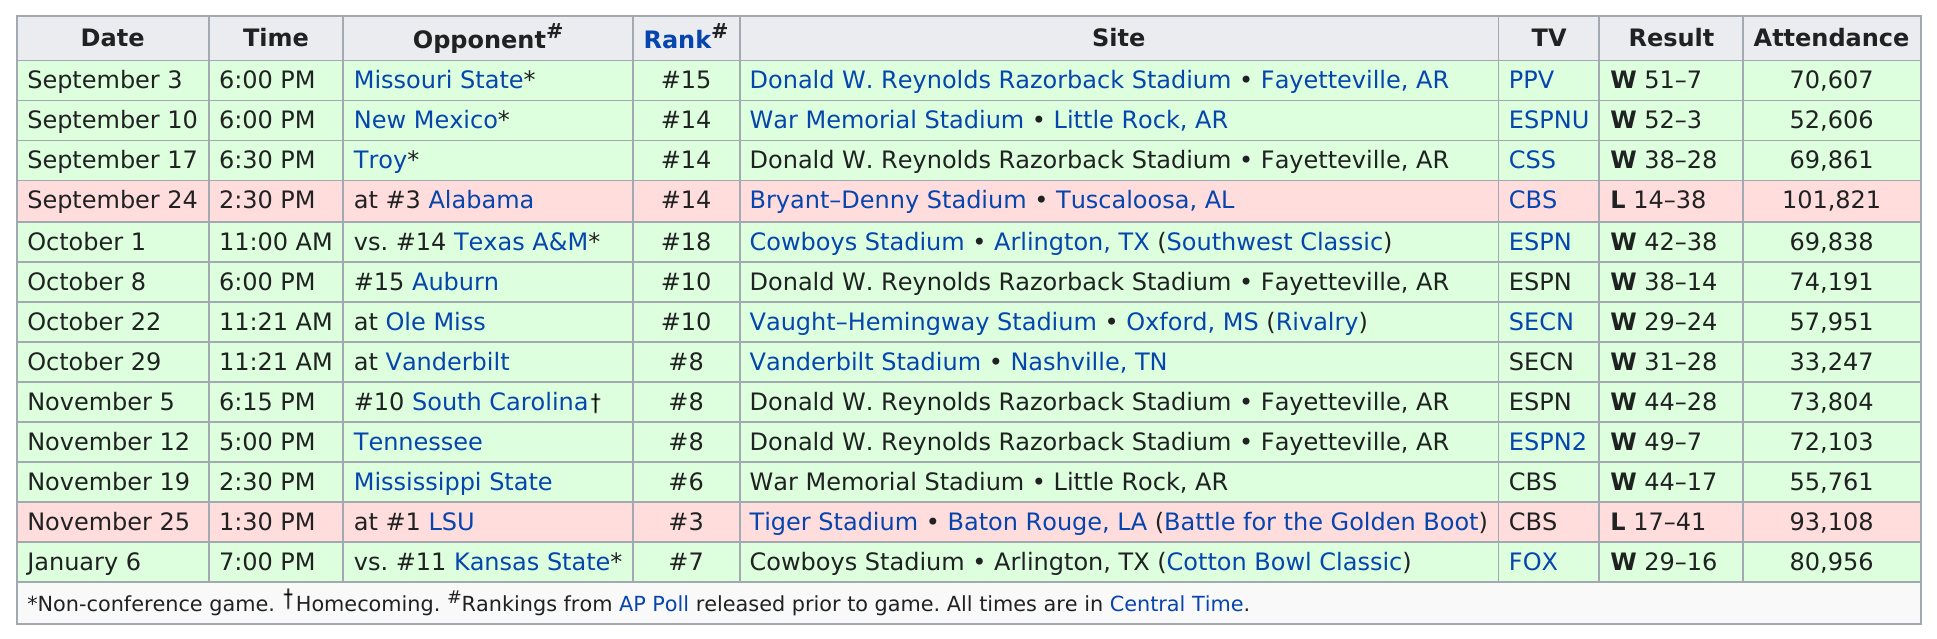Point out several critical features in this image. The difference in attendance between November 5 and November 25 in 1930 was 19,304 attendees. Kansas State is the only team this team faced in January, during the Cotton Bowl. The top result on the chart is a W with a score of 51-7. Auburn's game at home had the most attendance. On October 29, the Chicago Bears defeated the Green Bay Packers with a score of 44-28. 